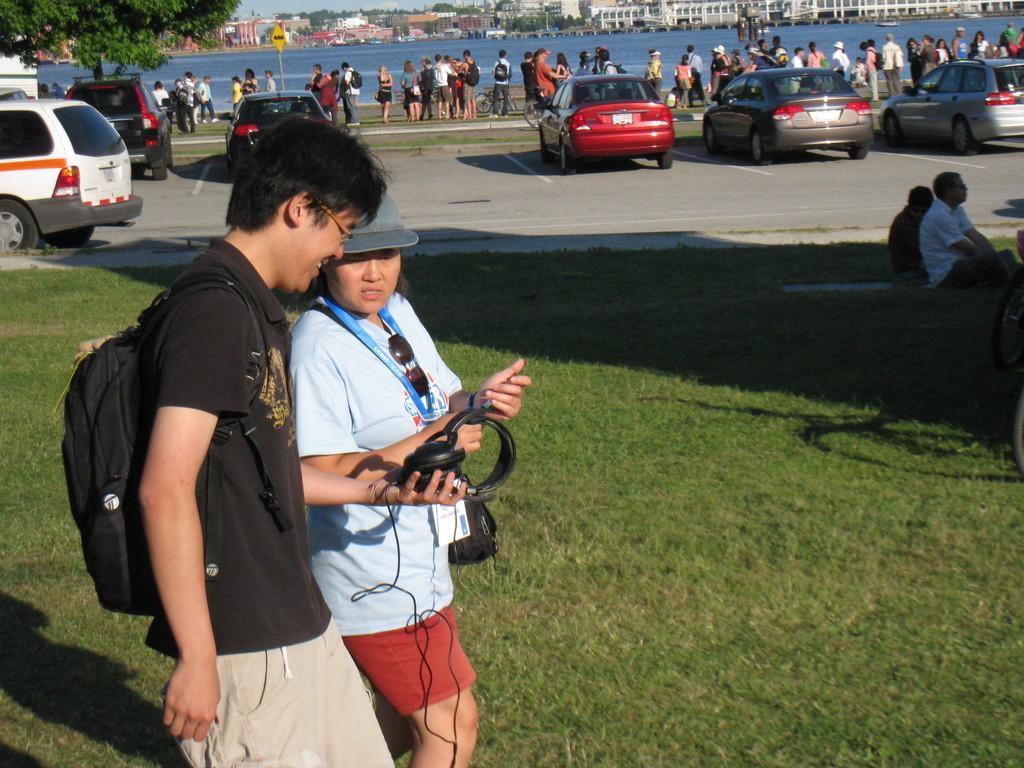Please provide a concise description of this image. In the center of the image we can see man and woman walking on the grass. In the background we can see persons, vehicles on road, trees, water, sign boards, buildings and sky. 